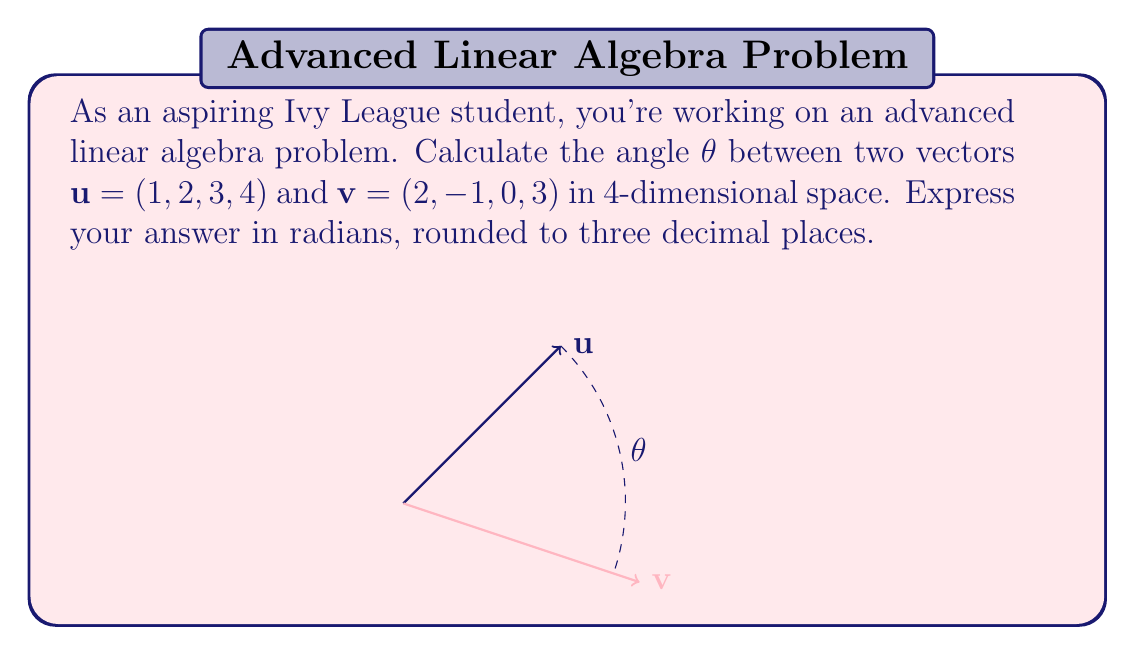What is the answer to this math problem? To find the angle between two vectors in n-dimensional space, we use the dot product formula:

$$\cos \theta = \frac{\mathbf{u} \cdot \mathbf{v}}{|\mathbf{u}||\mathbf{v}|}$$

Step 1: Calculate the dot product $\mathbf{u} \cdot \mathbf{v}$
$$\mathbf{u} \cdot \mathbf{v} = (1)(2) + (2)(-1) + (3)(0) + (4)(3) = 2 - 2 + 0 + 12 = 12$$

Step 2: Calculate the magnitudes $|\mathbf{u}|$ and $|\mathbf{v}|$
$$|\mathbf{u}| = \sqrt{1^2 + 2^2 + 3^2 + 4^2} = \sqrt{30}$$
$$|\mathbf{v}| = \sqrt{2^2 + (-1)^2 + 0^2 + 3^2} = \sqrt{14}$$

Step 3: Substitute into the formula
$$\cos \theta = \frac{12}{\sqrt{30}\sqrt{14}}$$

Step 4: Solve for $\theta$ using inverse cosine
$$\theta = \arccos\left(\frac{12}{\sqrt{30}\sqrt{14}}\right)$$

Step 5: Calculate and round to three decimal places
$$\theta \approx 0.876 \text{ radians}$$
Answer: $0.876$ radians 